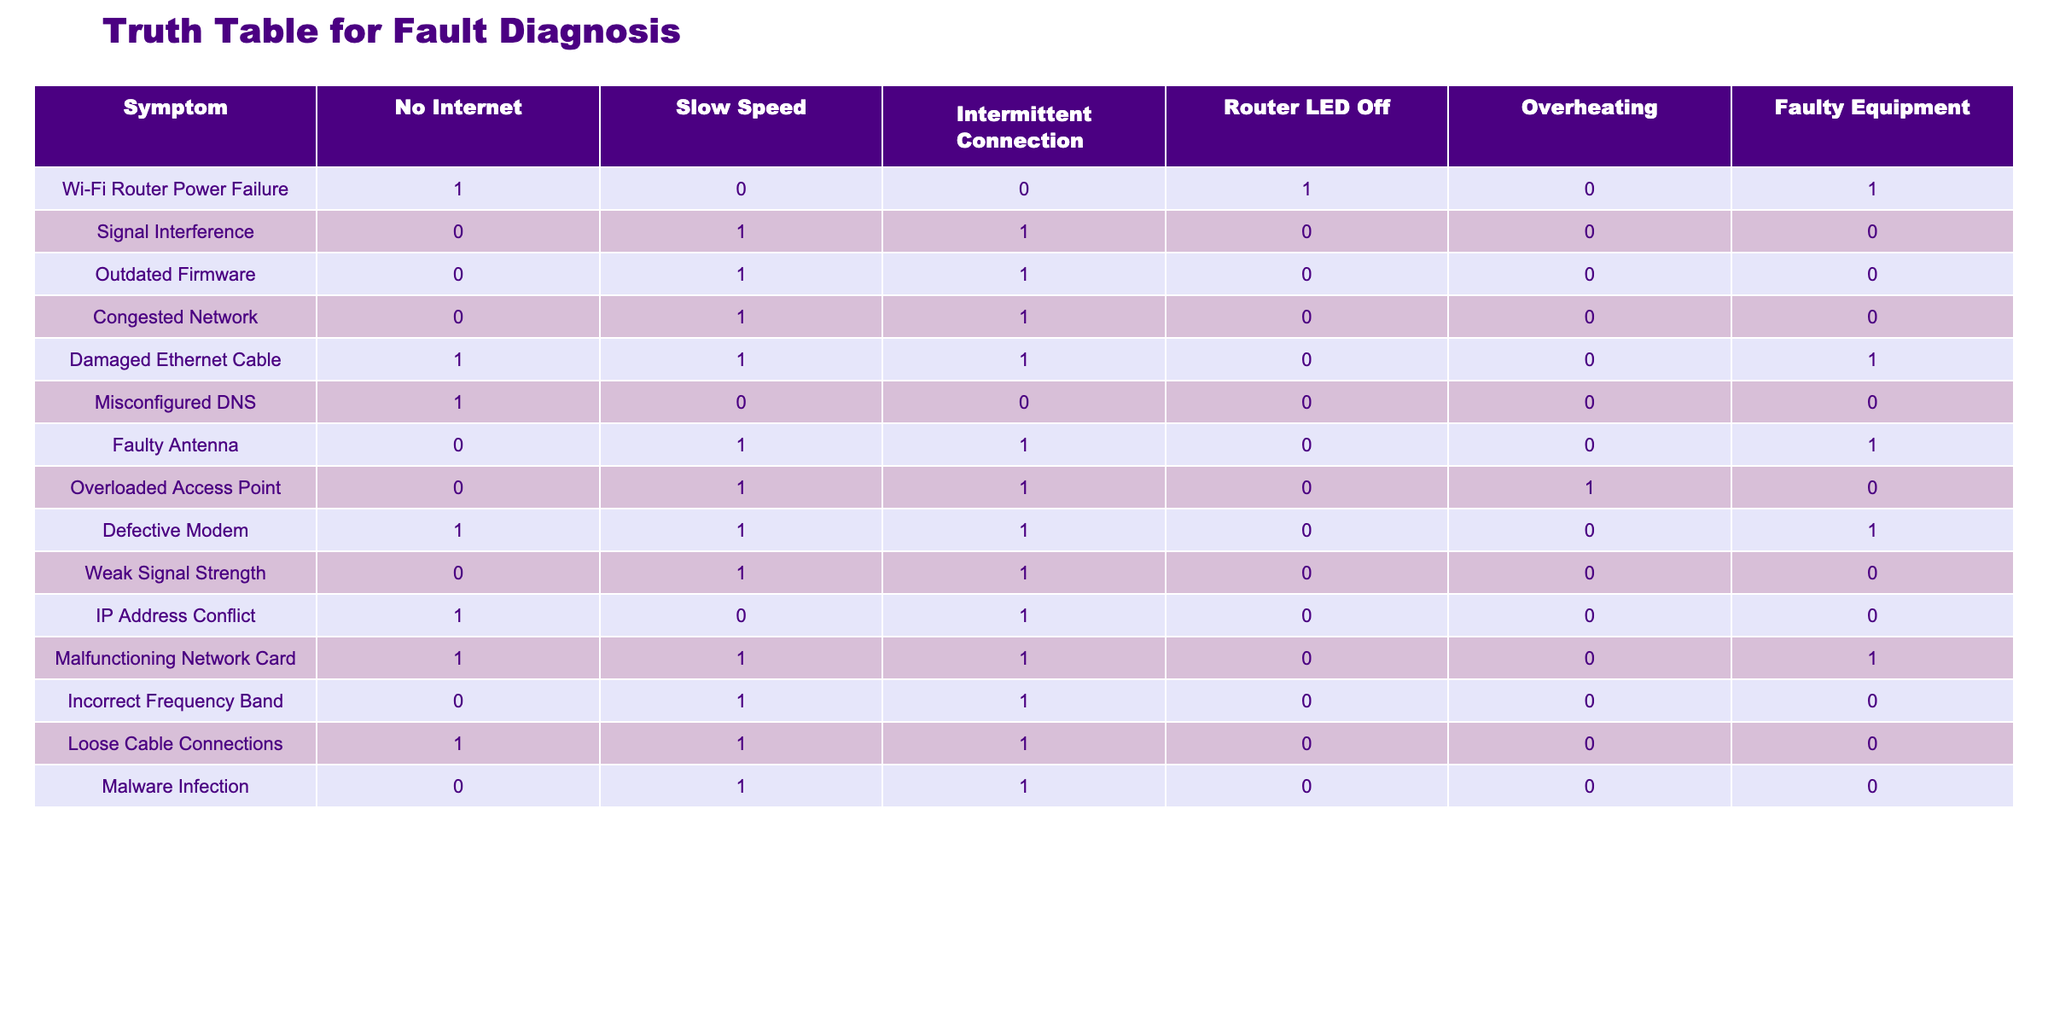What symptom is associated with both a faulty equipment diagnosis and slow speed? Looking at the table, the symptoms that have a '1' in both the Faulty Equipment column and the Slow Speed column include: Signal Interference, Outdated Firmware, Congested Network, Faulty Antenna, and Malfunctioning Network Card. The first symptom only listed here is Signal Interference.
Answer: Signal Interference Does the "Overloaded Access Point" symptom lead to a diagnosis of faulty equipment? In the table, if we check the Overloaded Access Point row, we see that it has a '0' under the Faulty Equipment column, indicating that it does not lead to that diagnosis.
Answer: No What is the total number of symptoms indicating "No Internet" and have "Overheating"? We need to count symptoms that have a '1' in the No Internet column and a '1' in the Overheating column. We check each row: Wi-Fi Router Power Failure (1,0), Damaged Ethernet Cable (1,0), Misconfigured DNS (1,0), IP Address Conflict (1,0), and the other symptoms do not qualify. The total count of symptoms meeting both criteria is 1.
Answer: 1 Which symptom shows the highest number of indications (total of all 1s across the columns)? To find the symptom with the highest number of '1's, we will sum the '1's for each symptom: Wi-Fi Router Power Failure (3), Signal Interference (3), Outdated Firmware (3), Congested Network (3), Damaged Ethernet Cable (4), Misconfigured DNS (1), Faulty Antenna (3), Overloaded Access Point (3), Defective Modem (4), Weak Signal Strength (3), IP Address Conflict (2), Malfunctioning Network Card (4), Incorrect Frequency Band (3), Loose Cable Connections (3), and Malware Infection (3). The highest sum is 4. The corresponding symptoms are Damaged Ethernet Cable, Defective Modem, and Malfunctioning Network Card.
Answer: Damaged Ethernet Cable, Defective Modem, and Malfunctioning Network Card Is overheating correlated with a power failure in the Wi-Fi router? Checking the values in the table for the Wi-Fi Router Power Failure, we can identify that the Overheating column has a value of '0', indicating there is no correlation with that specific symptom.
Answer: No 